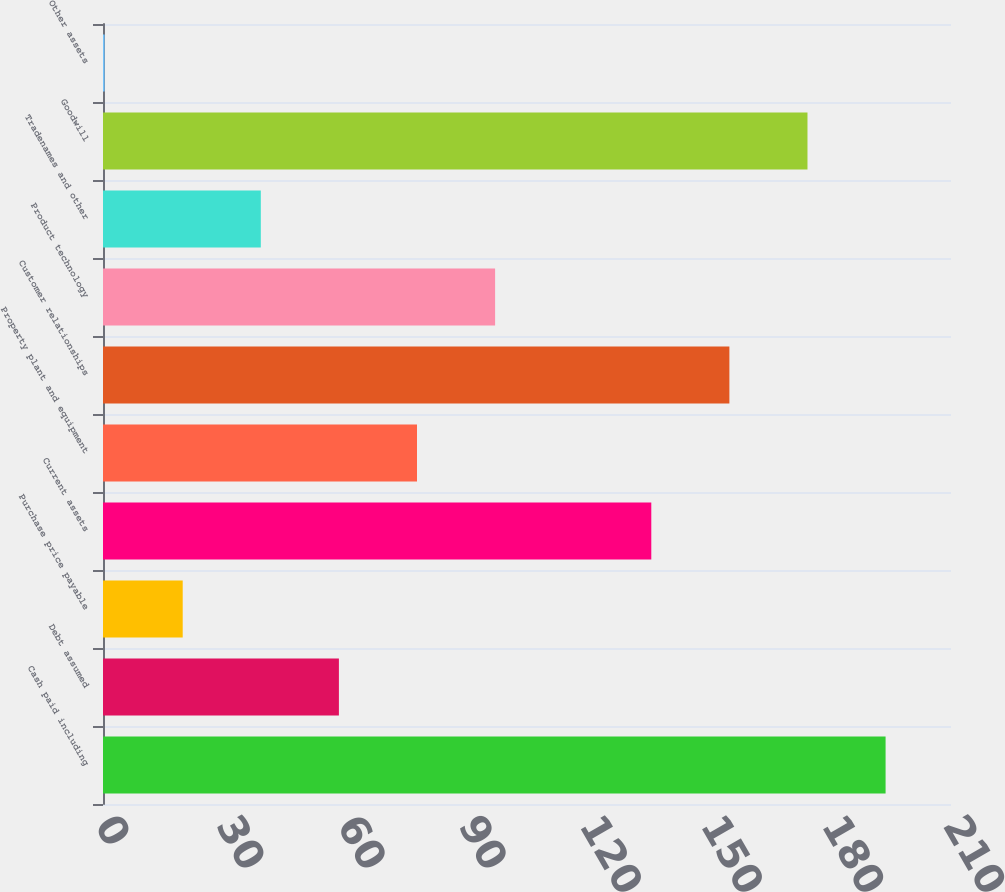Convert chart. <chart><loc_0><loc_0><loc_500><loc_500><bar_chart><fcel>Cash paid including<fcel>Debt assumed<fcel>Purchase price payable<fcel>Current assets<fcel>Property plant and equipment<fcel>Customer relationships<fcel>Product technology<fcel>Tradenames and other<fcel>Goodwill<fcel>Other assets<nl><fcel>193.8<fcel>58.42<fcel>19.74<fcel>135.78<fcel>77.76<fcel>155.12<fcel>97.1<fcel>39.08<fcel>174.46<fcel>0.4<nl></chart> 